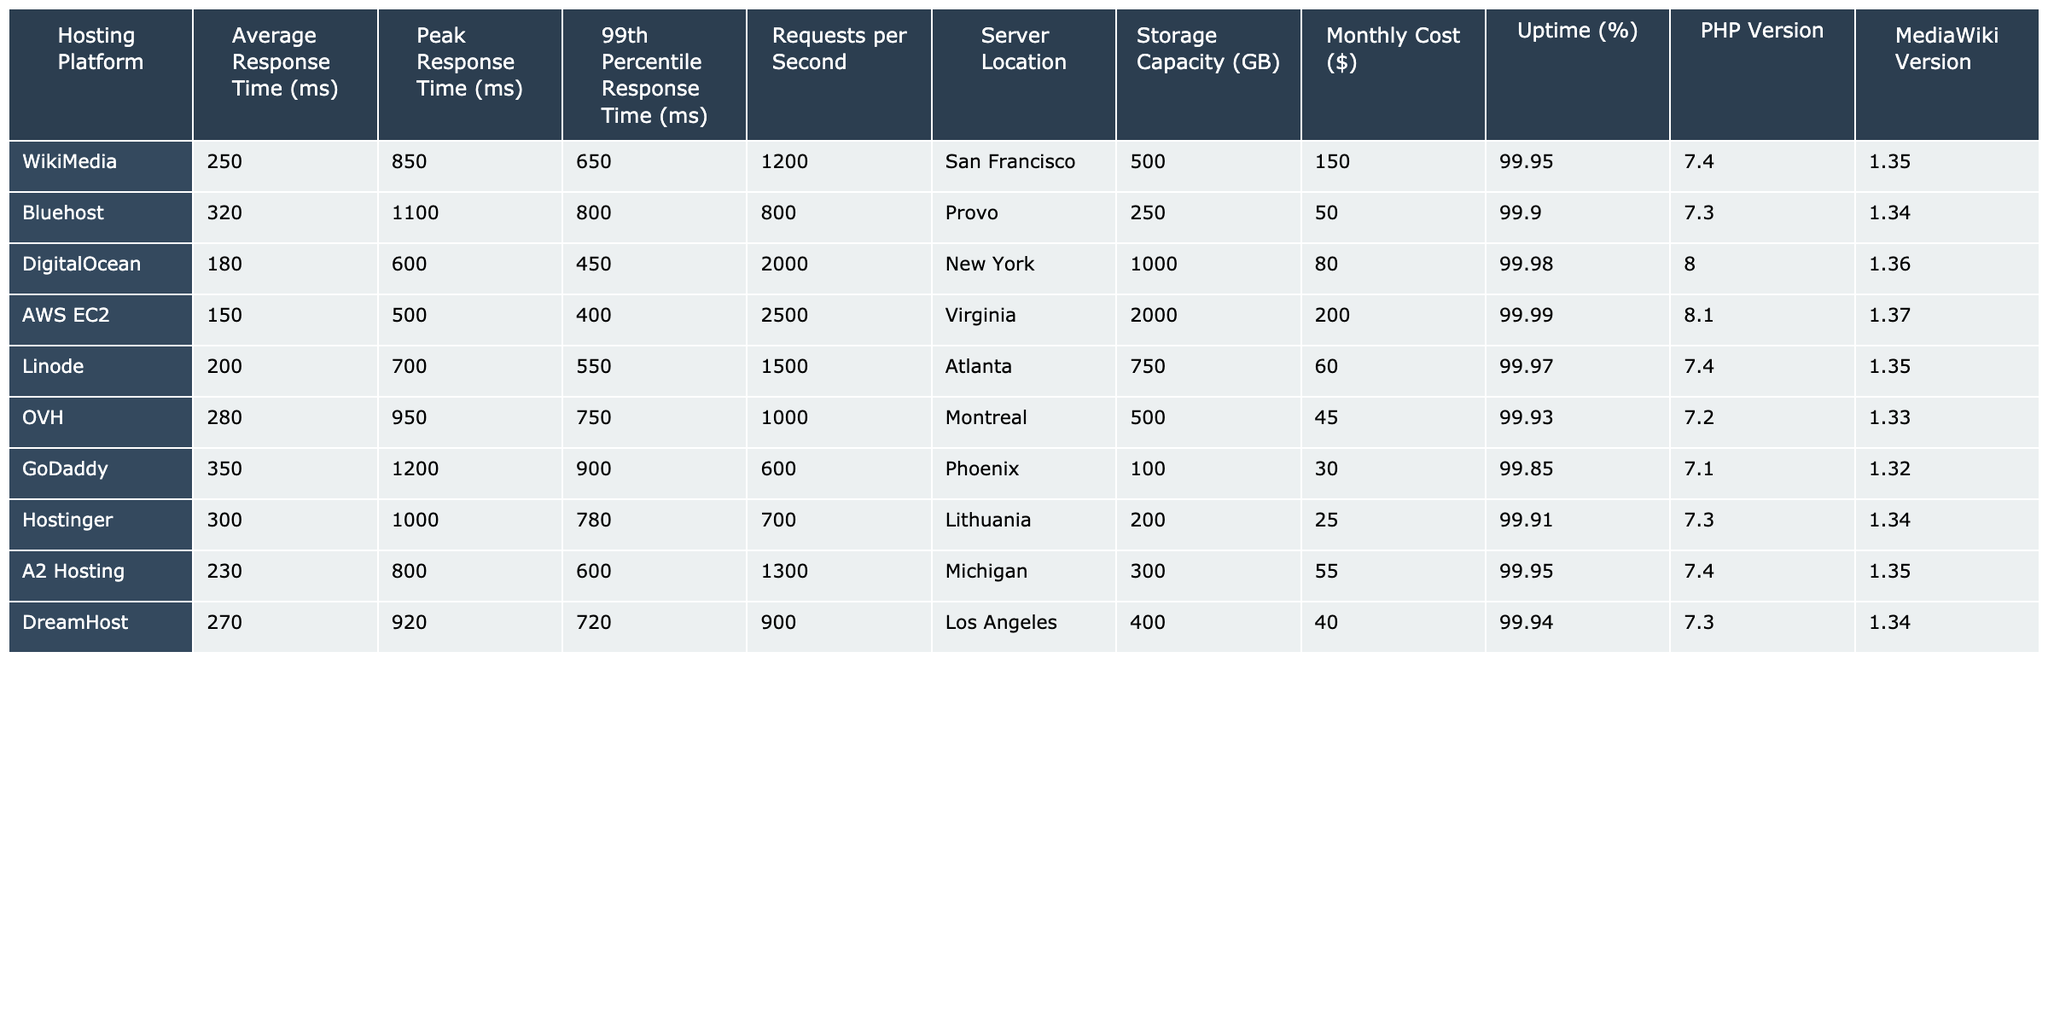What is the average response time for Bluehost? The table lists the average response time for Bluehost as 320 ms.
Answer: 320 ms Which hosting platform has the highest peak response time? The peak response time for GoDaddy is 1200 ms, which is the highest compared to other platforms listed.
Answer: GoDaddy Is the uptime for DigitalOcean greater than 99%? The uptime for DigitalOcean is 99.98%, which is indeed greater than 99%.
Answer: Yes What is the difference in average response time between WikiMedia and A2 Hosting? The average response time for WikiMedia is 250 ms, and for A2 Hosting, it’s 230 ms. The difference is 250 - 230 = 20 ms.
Answer: 20 ms Which hosting platform has the lowest monthly cost, and what is the value? Hostinger has the lowest monthly cost of $25 listed in the table.
Answer: $25 What is the average PHP version for all hosting platforms? The PHP versions listed are 7.4, 7.3, 8.0, 8.1, 7.4, 7.2, 7.1, 7.3, 7.4, and 7.3. Summing them gives 7.4 + 7.3 + 8.0 + 8.1 + 7.4 + 7.2 + 7.1 + 7.3 + 7.4 + 7.3 = 81. The average is 81/10 = 7.81.
Answer: 7.81 How many hosting platforms have an uptime of 99.95% or higher? The uptime percentages for platforms with 99.95% or higher are WikiMedia (99.95%), AWS EC2 (99.99%), A2 Hosting (99.95%), DigitalOcean (99.98%), and Linode (99.97%). This totals to five platforms.
Answer: 5 Is the storage capacity greater for AWS EC2 compared to Bluehost? The storage capacity for AWS EC2 is 2000 GB, which is indeed greater than Bluehost's 250 GB.
Answer: Yes What is the total number of requests per second for all platforms combined? The requests per second are summed up as follows: 1200 + 800 + 2000 + 2500 + 1500 + 1000 + 600 + 700 + 1300 + 900 = 10600 requests per second.
Answer: 10600 What is the maximum mediawiki version used by any hosting platform? The MediaWiki versions listed are 1.35, 1.34, 1.36, 1.37, 1.35, 1.33, 1.32, 1.34, 1.35, and 1.34. The maximum is 1.37 from AWS EC2.
Answer: 1.37 